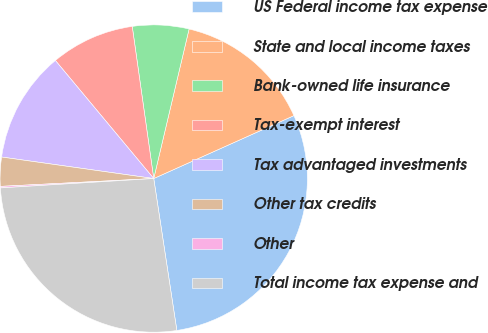Convert chart. <chart><loc_0><loc_0><loc_500><loc_500><pie_chart><fcel>US Federal income tax expense<fcel>State and local income taxes<fcel>Bank-owned life insurance<fcel>Tax-exempt interest<fcel>Tax advantaged investments<fcel>Other tax credits<fcel>Other<fcel>Total income tax expense and<nl><fcel>29.31%<fcel>14.59%<fcel>5.93%<fcel>8.82%<fcel>11.71%<fcel>3.05%<fcel>0.16%<fcel>26.43%<nl></chart> 